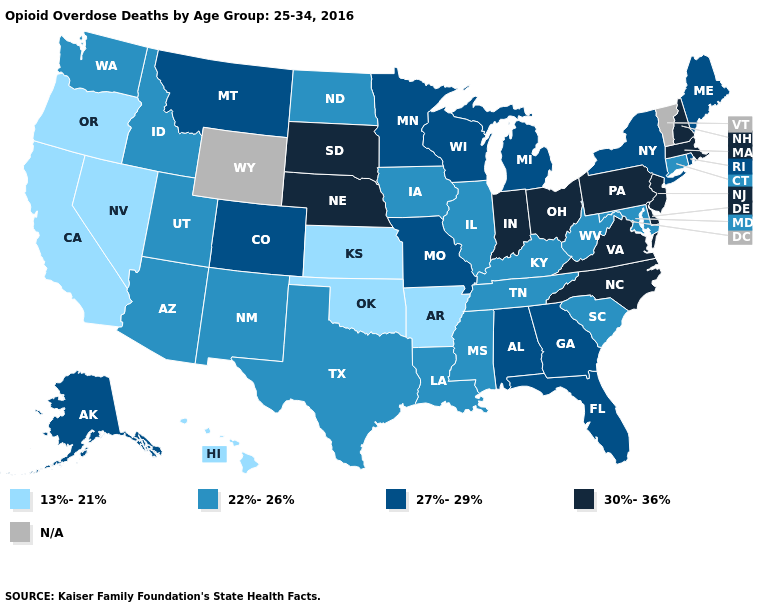What is the value of California?
Keep it brief. 13%-21%. Does the first symbol in the legend represent the smallest category?
Quick response, please. Yes. What is the highest value in the West ?
Give a very brief answer. 27%-29%. Does the first symbol in the legend represent the smallest category?
Quick response, please. Yes. What is the value of Arkansas?
Concise answer only. 13%-21%. Does the map have missing data?
Concise answer only. Yes. Does the map have missing data?
Answer briefly. Yes. What is the value of Tennessee?
Answer briefly. 22%-26%. Among the states that border Missouri , does Tennessee have the highest value?
Short answer required. No. Which states hav the highest value in the Northeast?
Answer briefly. Massachusetts, New Hampshire, New Jersey, Pennsylvania. Name the states that have a value in the range 27%-29%?
Give a very brief answer. Alabama, Alaska, Colorado, Florida, Georgia, Maine, Michigan, Minnesota, Missouri, Montana, New York, Rhode Island, Wisconsin. What is the value of Rhode Island?
Answer briefly. 27%-29%. Does Hawaii have the lowest value in the USA?
Give a very brief answer. Yes. Which states have the lowest value in the Northeast?
Short answer required. Connecticut. What is the value of Pennsylvania?
Answer briefly. 30%-36%. 